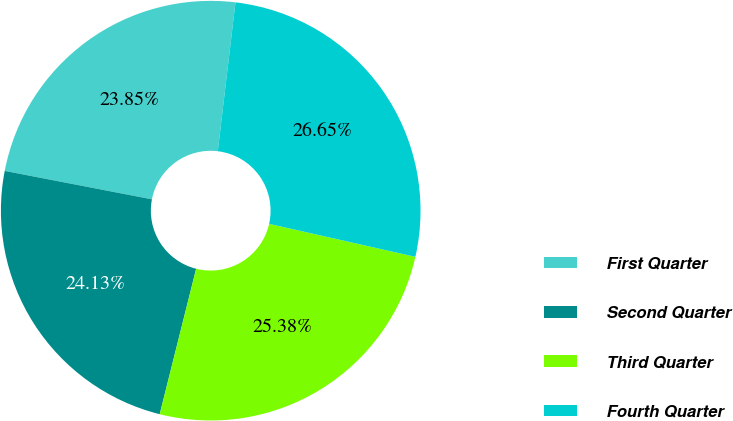Convert chart. <chart><loc_0><loc_0><loc_500><loc_500><pie_chart><fcel>First Quarter<fcel>Second Quarter<fcel>Third Quarter<fcel>Fourth Quarter<nl><fcel>23.85%<fcel>24.13%<fcel>25.38%<fcel>26.65%<nl></chart> 